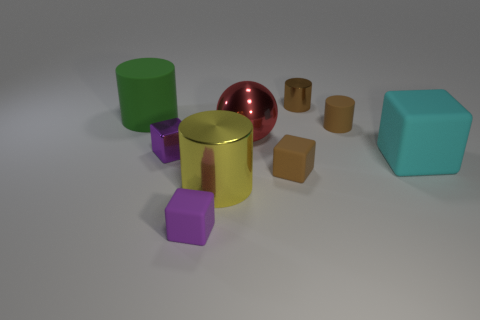Subtract all small brown matte blocks. How many blocks are left? 3 Subtract all purple blocks. How many blocks are left? 2 Subtract all cubes. How many objects are left? 5 Subtract all gray cylinders. Subtract all blue spheres. How many cylinders are left? 4 Subtract all red spheres. How many purple cylinders are left? 0 Subtract all green rubber things. Subtract all purple rubber things. How many objects are left? 7 Add 5 big cyan rubber cubes. How many big cyan rubber cubes are left? 6 Add 9 big green matte things. How many big green matte things exist? 10 Add 1 tiny matte things. How many objects exist? 10 Subtract 1 cyan blocks. How many objects are left? 8 